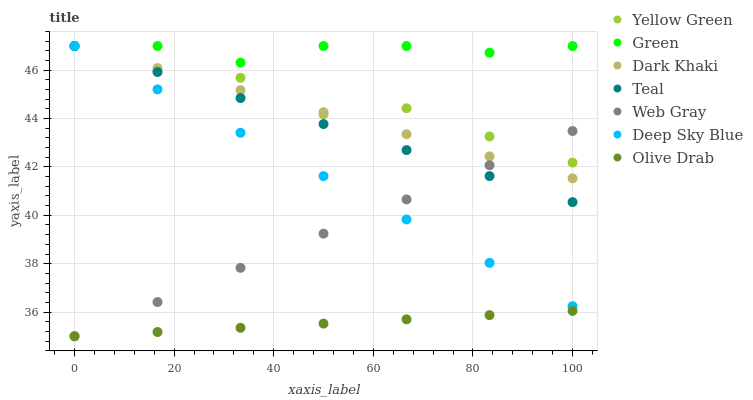Does Olive Drab have the minimum area under the curve?
Answer yes or no. Yes. Does Green have the maximum area under the curve?
Answer yes or no. Yes. Does Web Gray have the minimum area under the curve?
Answer yes or no. No. Does Web Gray have the maximum area under the curve?
Answer yes or no. No. Is Dark Khaki the smoothest?
Answer yes or no. Yes. Is Yellow Green the roughest?
Answer yes or no. Yes. Is Web Gray the smoothest?
Answer yes or no. No. Is Web Gray the roughest?
Answer yes or no. No. Does Web Gray have the lowest value?
Answer yes or no. Yes. Does Yellow Green have the lowest value?
Answer yes or no. No. Does Deep Sky Blue have the highest value?
Answer yes or no. Yes. Does Web Gray have the highest value?
Answer yes or no. No. Is Web Gray less than Green?
Answer yes or no. Yes. Is Dark Khaki greater than Olive Drab?
Answer yes or no. Yes. Does Web Gray intersect Dark Khaki?
Answer yes or no. Yes. Is Web Gray less than Dark Khaki?
Answer yes or no. No. Is Web Gray greater than Dark Khaki?
Answer yes or no. No. Does Web Gray intersect Green?
Answer yes or no. No. 